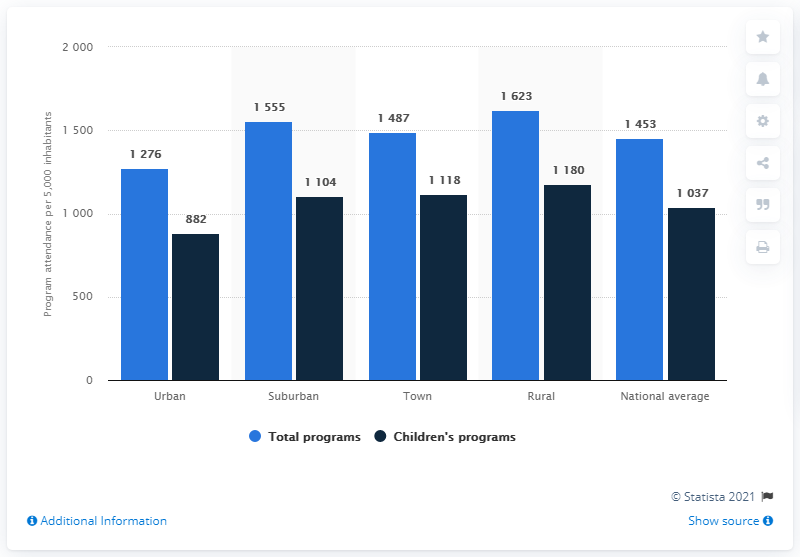Highlight a few significant elements in this photo. The location with the highest number of total programs is rural. The total number of programs, excluding the national average, is 5941. 